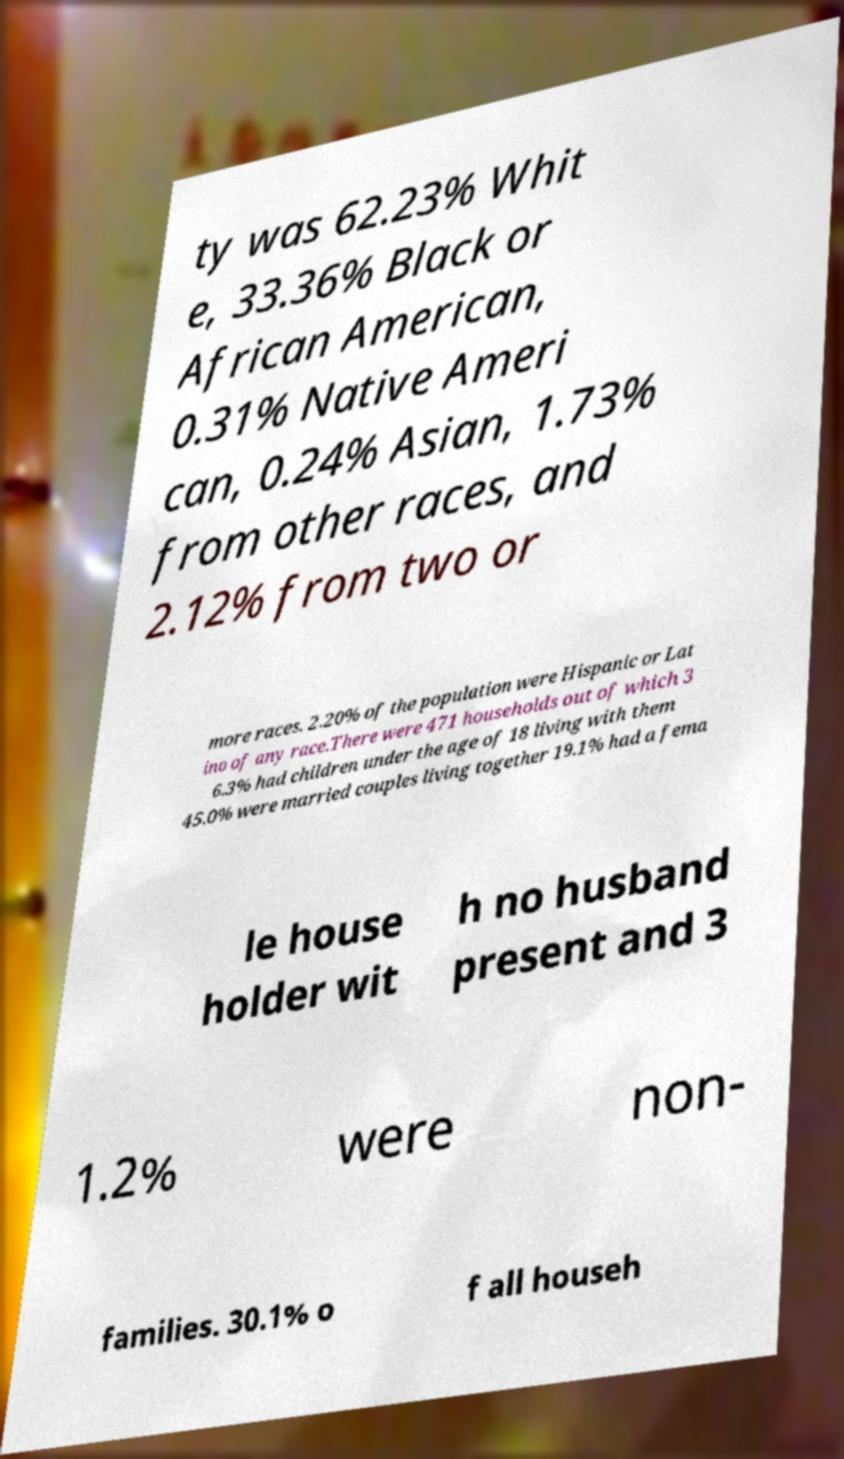Could you assist in decoding the text presented in this image and type it out clearly? ty was 62.23% Whit e, 33.36% Black or African American, 0.31% Native Ameri can, 0.24% Asian, 1.73% from other races, and 2.12% from two or more races. 2.20% of the population were Hispanic or Lat ino of any race.There were 471 households out of which 3 6.3% had children under the age of 18 living with them 45.0% were married couples living together 19.1% had a fema le house holder wit h no husband present and 3 1.2% were non- families. 30.1% o f all househ 